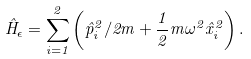Convert formula to latex. <formula><loc_0><loc_0><loc_500><loc_500>\hat { H } _ { \epsilon } = \sum _ { i = 1 } ^ { 2 } \left ( \hat { p } _ { i } ^ { 2 } / 2 m + \frac { 1 } { 2 } m \omega ^ { 2 } \hat { x } _ { i } ^ { 2 } \right ) .</formula> 